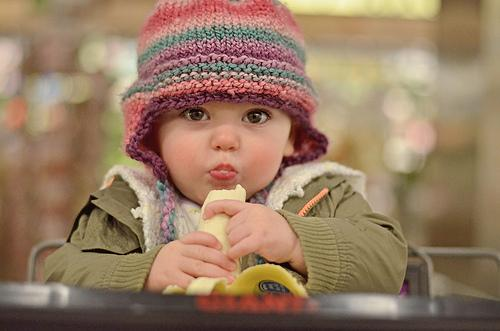Briefly explain what color the zipper on the jacket is and the position of the metal bar in the image. The zipper is orange in color, and there is a metal bar located at the top-right corner of the image. What is the main activity that the child is engaged in? The child is eating a peeled yellow banana. In a concise statement, delineate the key features of the image with the focus on the child and the fruit. A young girl with brown eyes wears a green jacket and a colorful beanie, eating a peeled yellow banana with a blue sticker on its peel. Concisely describe the child's hands and what they are doing. The child's hands are holding a partially peeled yellow banana while she takes a bite. Identify the clothing items the little girl is wearing, including their colors. The child is wearing a green jacket with a hood and a knitted beanie that's purple, green, and pink. Compose a short scene description focusing on the little girl's interaction with the fruit and her clothing. In a heartwarming moment, a young girl wearing a colorful beanie and green jacket enjoys a bright yellow banana, peeling back the skin to reveal a blue sticker. Enumerate three aspects of the image related to the little girl's appearance or position. The little girl has brown eyes, a green jacket with a hood, and is looking directly at the camera. Please give a brief and catchy caption for this image that could be used in an advertisement. Cuteness overload: Cozy and colorful kiddo snacking on a healthy banana treat. Choose a phrase that would best reference the banana's appearance and sticker. A vibrant, peeled yellow banana sports a contrasting blue sticker on its peel. 